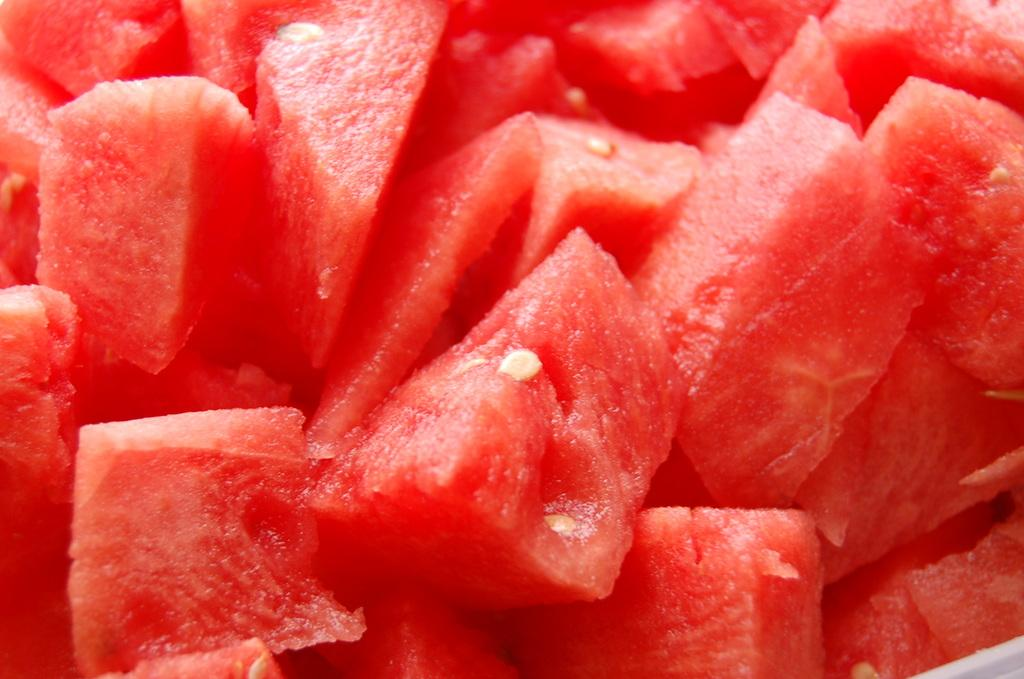What type of food is visible in the image? There are watermelon slices in the image. What grade is the watermelon in the image? The concept of a "grade" does not apply to watermelon, as it is a fruit and not a student or a product with varying quality levels. 